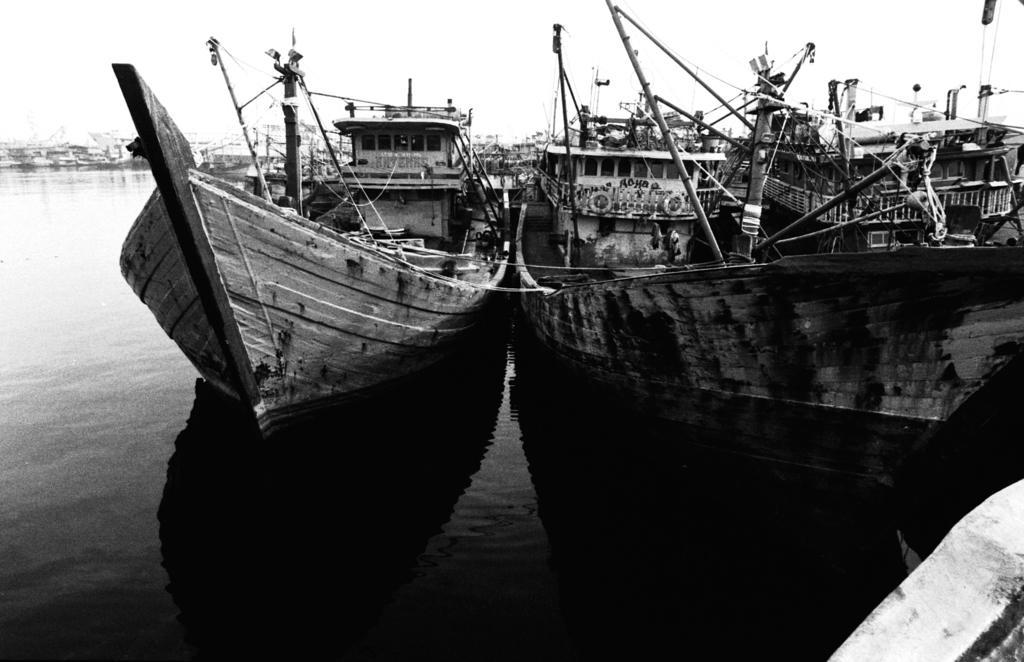How would you summarize this image in a sentence or two? This is a black and picture of boats on the water , and in the background there is sky. 